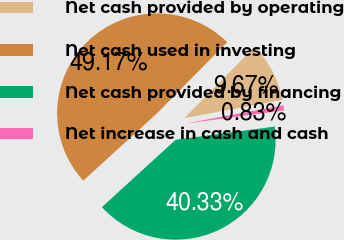Convert chart. <chart><loc_0><loc_0><loc_500><loc_500><pie_chart><fcel>Net cash provided by operating<fcel>Net cash used in investing<fcel>Net cash provided by financing<fcel>Net increase in cash and cash<nl><fcel>9.67%<fcel>49.17%<fcel>40.33%<fcel>0.83%<nl></chart> 